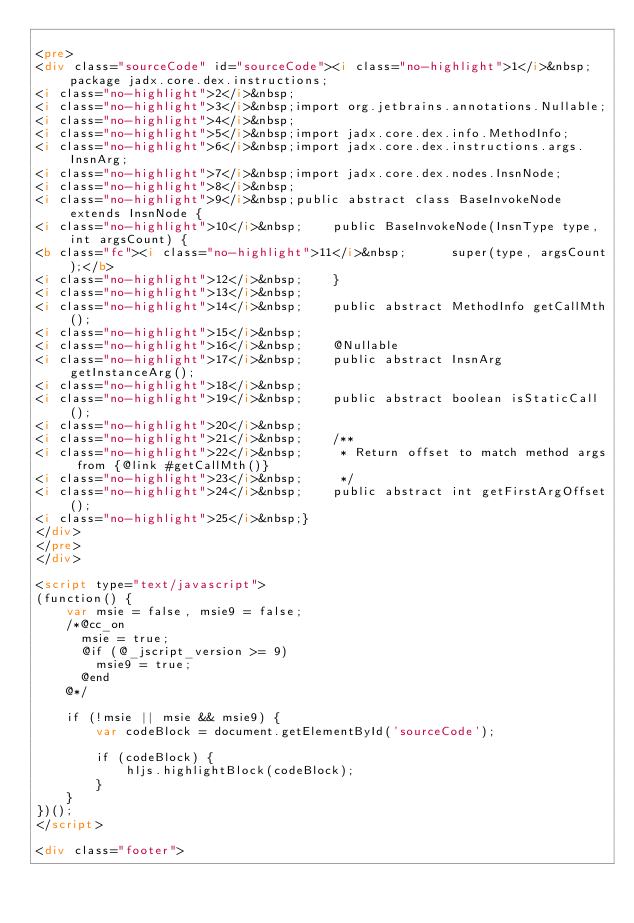Convert code to text. <code><loc_0><loc_0><loc_500><loc_500><_HTML_>
<pre>
<div class="sourceCode" id="sourceCode"><i class="no-highlight">1</i>&nbsp;package jadx.core.dex.instructions;
<i class="no-highlight">2</i>&nbsp;
<i class="no-highlight">3</i>&nbsp;import org.jetbrains.annotations.Nullable;
<i class="no-highlight">4</i>&nbsp;
<i class="no-highlight">5</i>&nbsp;import jadx.core.dex.info.MethodInfo;
<i class="no-highlight">6</i>&nbsp;import jadx.core.dex.instructions.args.InsnArg;
<i class="no-highlight">7</i>&nbsp;import jadx.core.dex.nodes.InsnNode;
<i class="no-highlight">8</i>&nbsp;
<i class="no-highlight">9</i>&nbsp;public abstract class BaseInvokeNode extends InsnNode {
<i class="no-highlight">10</i>&nbsp;	public BaseInvokeNode(InsnType type, int argsCount) {
<b class="fc"><i class="no-highlight">11</i>&nbsp;		super(type, argsCount);</b>
<i class="no-highlight">12</i>&nbsp;	}
<i class="no-highlight">13</i>&nbsp;
<i class="no-highlight">14</i>&nbsp;	public abstract MethodInfo getCallMth();
<i class="no-highlight">15</i>&nbsp;
<i class="no-highlight">16</i>&nbsp;	@Nullable
<i class="no-highlight">17</i>&nbsp;	public abstract InsnArg getInstanceArg();
<i class="no-highlight">18</i>&nbsp;
<i class="no-highlight">19</i>&nbsp;	public abstract boolean isStaticCall();
<i class="no-highlight">20</i>&nbsp;
<i class="no-highlight">21</i>&nbsp;	/**
<i class="no-highlight">22</i>&nbsp;	 * Return offset to match method args from {@link #getCallMth()}
<i class="no-highlight">23</i>&nbsp;	 */
<i class="no-highlight">24</i>&nbsp;	public abstract int getFirstArgOffset();
<i class="no-highlight">25</i>&nbsp;}
</div>
</pre>
</div>

<script type="text/javascript">
(function() {
    var msie = false, msie9 = false;
    /*@cc_on
      msie = true;
      @if (@_jscript_version >= 9)
        msie9 = true;
      @end
    @*/

    if (!msie || msie && msie9) {
        var codeBlock = document.getElementById('sourceCode');

        if (codeBlock) {
            hljs.highlightBlock(codeBlock);
        }
    }
})();
</script>

<div class="footer">
    </code> 